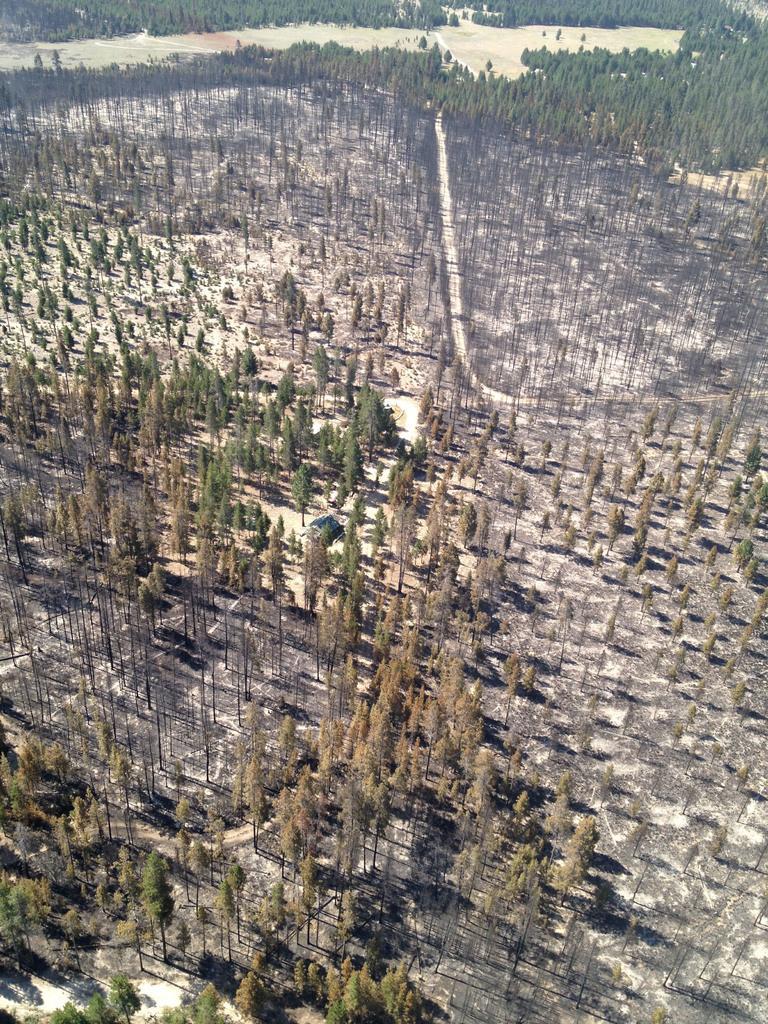In one or two sentences, can you explain what this image depicts? The picture is a forest. In this picture there are trees and some dry land. 